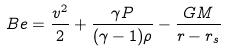<formula> <loc_0><loc_0><loc_500><loc_500>B e = \frac { v ^ { 2 } } { 2 } + \frac { \gamma P } { ( \gamma - 1 ) \rho } - \frac { G M } { r - r _ { s } }</formula> 